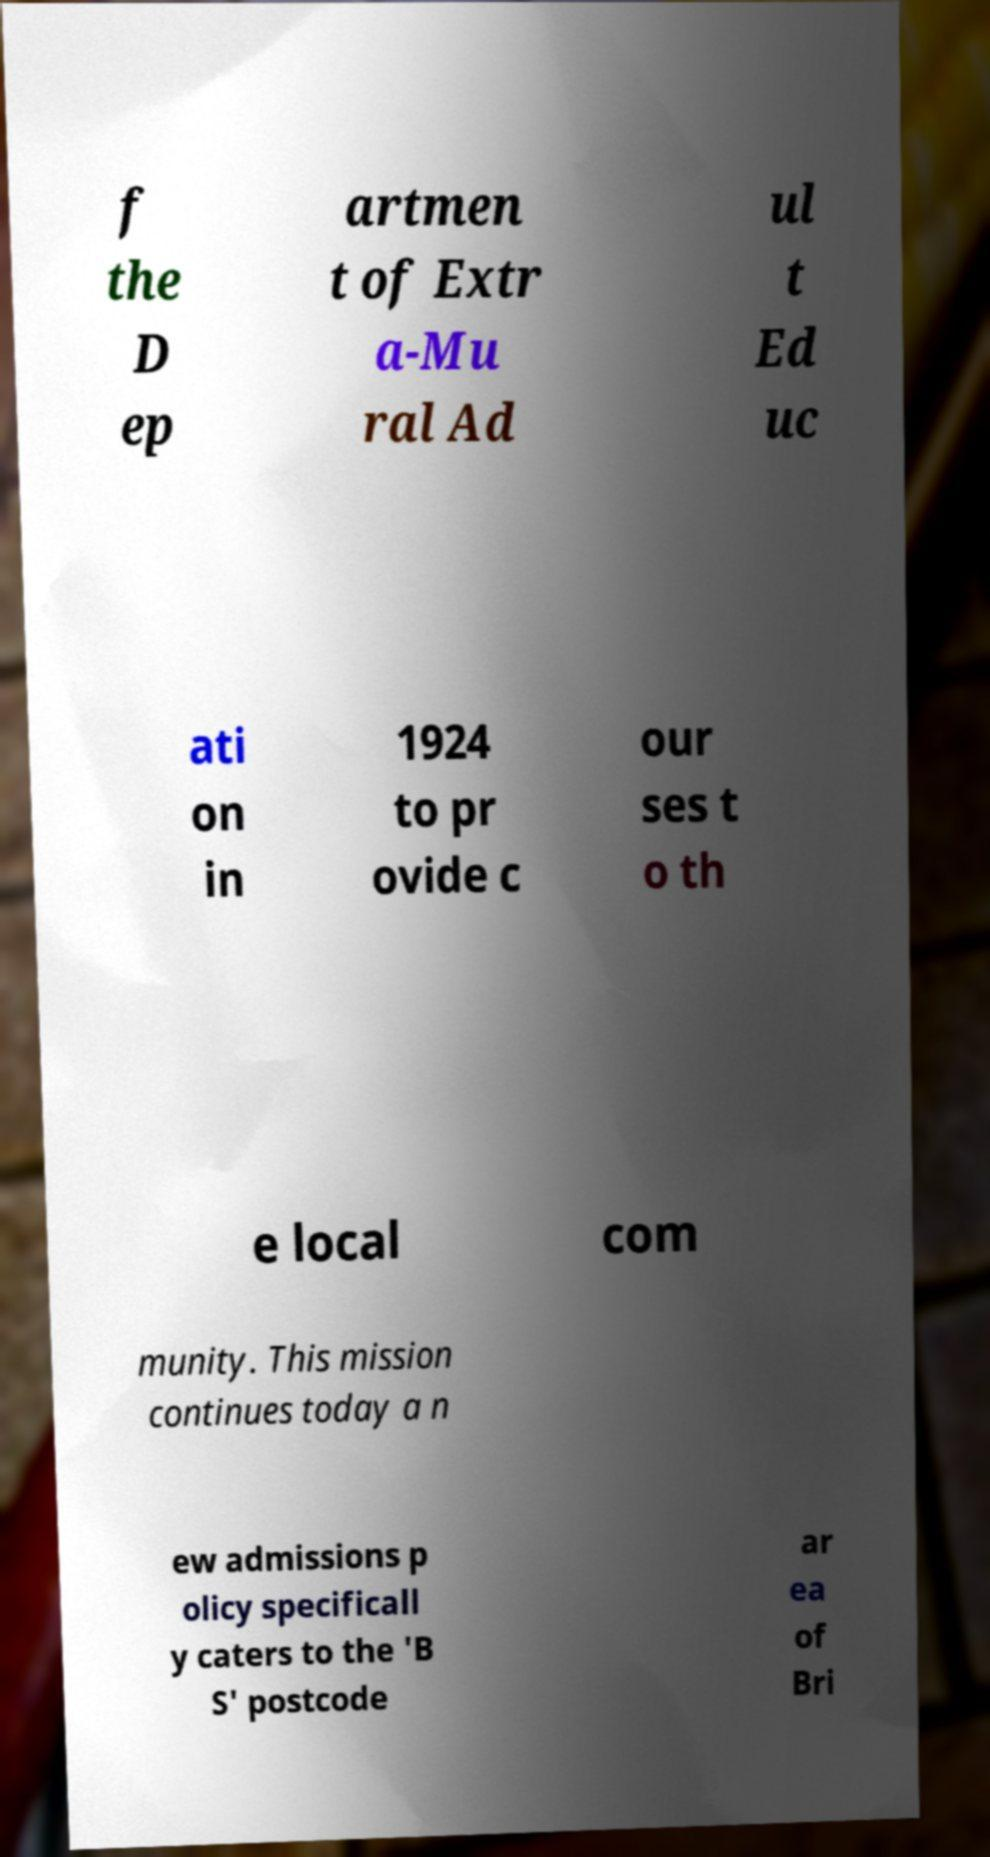Please identify and transcribe the text found in this image. f the D ep artmen t of Extr a-Mu ral Ad ul t Ed uc ati on in 1924 to pr ovide c our ses t o th e local com munity. This mission continues today a n ew admissions p olicy specificall y caters to the 'B S' postcode ar ea of Bri 